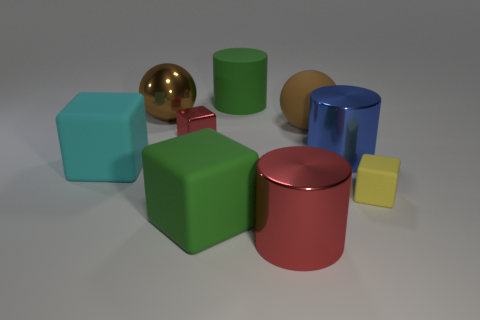The metallic thing that is the same color as the metallic cube is what shape?
Keep it short and to the point. Cylinder. How many big things have the same color as the large rubber cylinder?
Provide a short and direct response. 1. What size is the cylinder on the left side of the red metal object to the right of the tiny metal cube?
Ensure brevity in your answer.  Large. Are there any other cylinders that have the same size as the blue metal cylinder?
Provide a succinct answer. Yes. There is a brown ball left of the tiny red object; is it the same size as the green object in front of the big green rubber cylinder?
Your response must be concise. Yes. There is a large green thing that is in front of the large sphere behind the big brown rubber thing; what is its shape?
Give a very brief answer. Cube. There is a tiny red metal object; how many small red shiny objects are behind it?
Provide a short and direct response. 0. There is a big ball that is the same material as the tiny red cube; what is its color?
Offer a terse response. Brown. Is the size of the brown rubber ball the same as the green thing behind the blue metallic cylinder?
Your answer should be very brief. Yes. There is a blue thing behind the block that is to the right of the big green rubber thing that is behind the large cyan thing; how big is it?
Ensure brevity in your answer.  Large. 